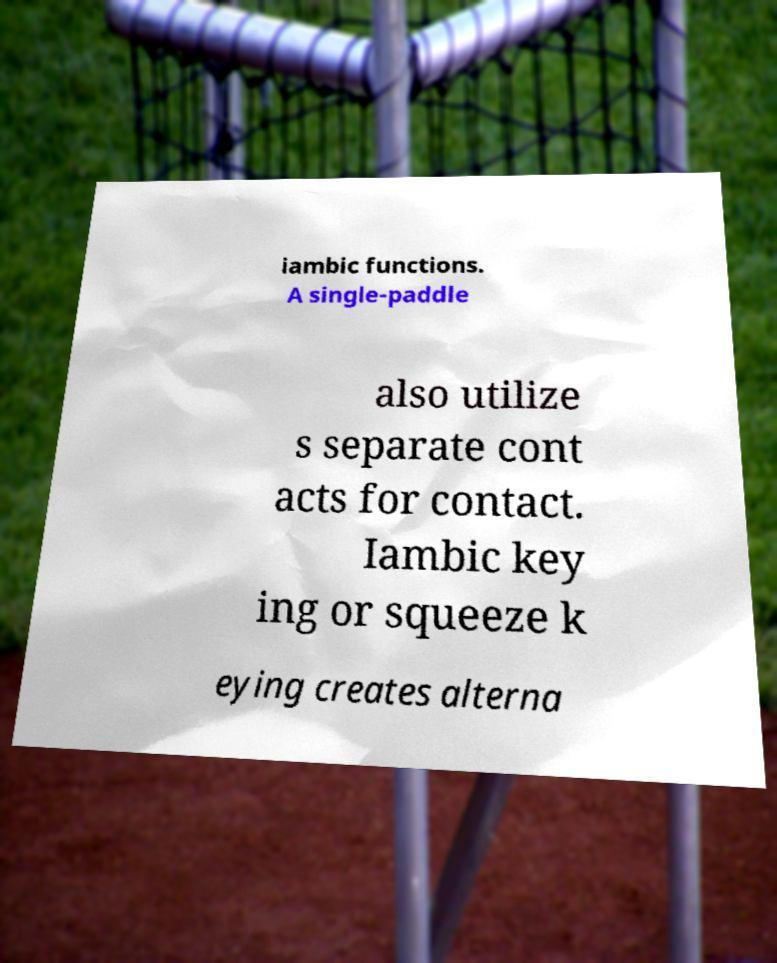I need the written content from this picture converted into text. Can you do that? iambic functions. A single-paddle also utilize s separate cont acts for contact. Iambic key ing or squeeze k eying creates alterna 